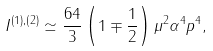<formula> <loc_0><loc_0><loc_500><loc_500>I ^ { \left ( 1 \right ) , \left ( 2 \right ) } \simeq \frac { 6 4 } { 3 } \left ( 1 \mp \frac { 1 } { 2 } \right ) \mu ^ { 2 } \alpha ^ { 4 } p ^ { 4 } ,</formula> 